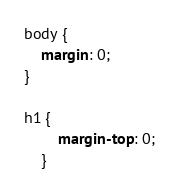Convert code to text. <code><loc_0><loc_0><loc_500><loc_500><_CSS_>body {
    margin: 0;
}

h1 {
        margin-top: 0;
    }</code> 